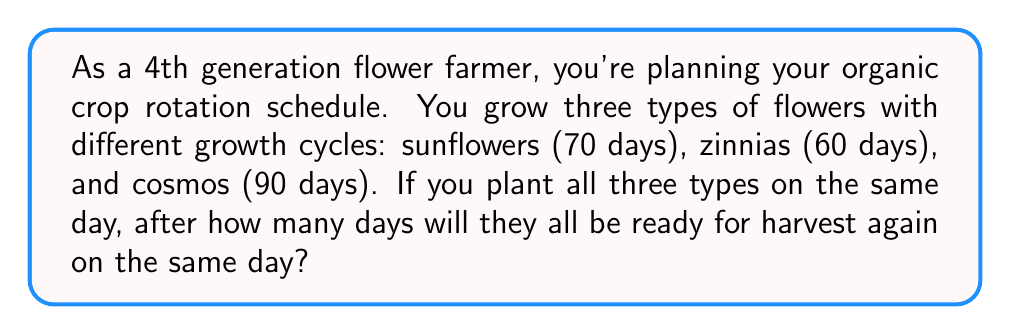Can you answer this question? To solve this problem, we need to find the least common multiple (LCM) of the growth cycles for sunflowers, zinnias, and cosmos.

Let's break it down step-by-step:

1. First, we need to find the prime factorization of each growth cycle:
   
   Sunflowers: $70 = 2 \times 5 \times 7$
   Zinnias: $60 = 2^2 \times 3 \times 5$
   Cosmos: $90 = 2 \times 3^2 \times 5$

2. To find the LCM, we take each prime factor to the highest power in which it occurs in any of the numbers:

   $LCM = 2^2 \times 3^2 \times 5 \times 7$

3. Now we can calculate the result:

   $$LCM = 2^2 \times 3^2 \times 5 \times 7 = 4 \times 9 \times 5 \times 7 = 1260$$

Therefore, after 1260 days, all three types of flowers will be ready for harvest on the same day again.

This solution ensures that we've accounted for the complete growth cycles of all three flower types, which is crucial for planning crop rotations in organic farming practices.
Answer: 1260 days 